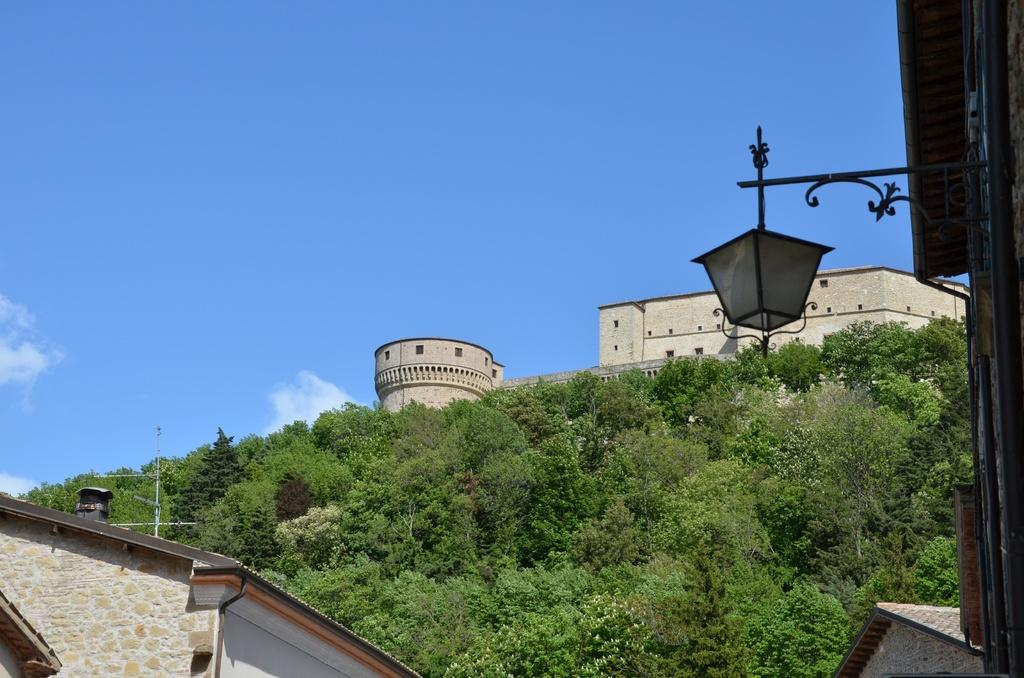What type of structure is present in the image? There is a building in the image. What is the purpose of the stand in the image? There is a light attached to a stand in the image, so the stand is likely for supporting the light. What type of vegetation can be seen in the image? There are trees in the image. What can be seen in the sky in the image? The sky is visible in the image. How many eggs are visible in the image? There are no eggs present in the image. 